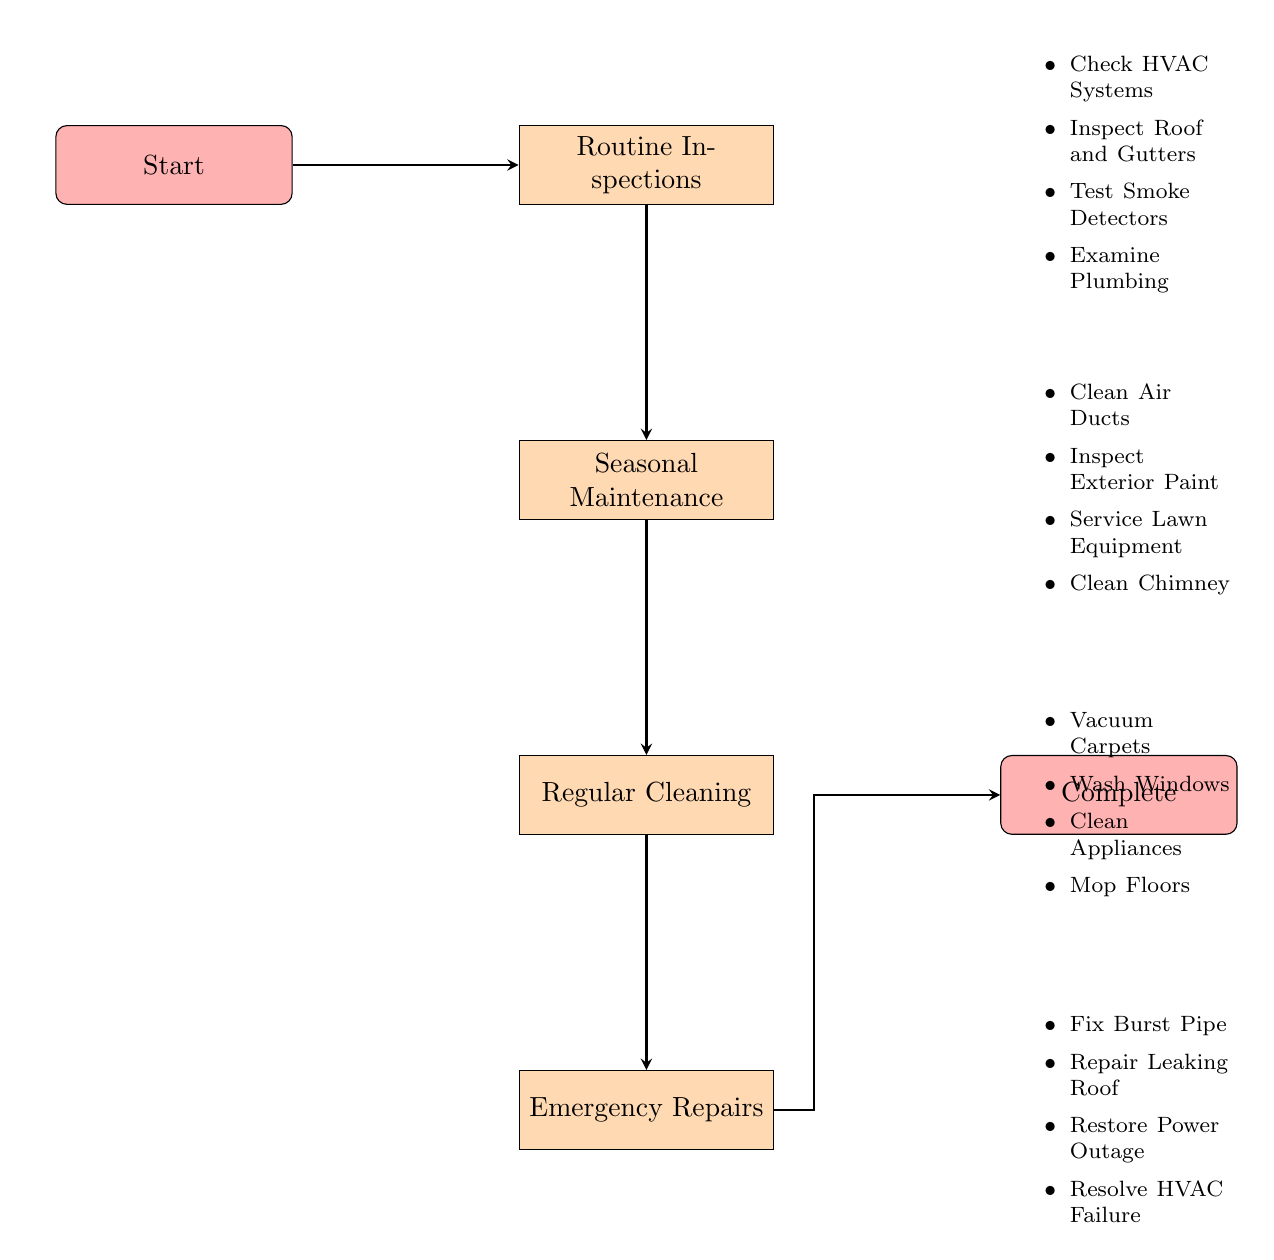What is the first node in the diagram? The first node in the diagram is labeled "Routine Inspections", which is directly after the "Start" node.
Answer: Routine Inspections How many actions are listed under "Regular Cleaning"? Counting the actions listed under "Regular Cleaning", there are four specific tasks mentioned: vacuum carpets, wash windows, clean kitchen appliances, and mop floors.
Answer: 4 What action is included in the "Emergency Repairs" node? Among the actions included in "Emergency Repairs", one specific task is to "Fix Burst Pipe".
Answer: Fix Burst Pipe What type of maintenance is done before "Seasonal Maintenance"? The type of maintenance that is done before "Seasonal Maintenance" is "Routine Inspections", which is directly linked in the flow chart to precede it.
Answer: Routine Inspections Which node follows "Regular Cleaning"? The node that follows "Regular Cleaning" in the flow of the diagram is "Emergency Repairs".
Answer: Emergency Repairs What is the last node in the flow chart? The last node in the flow chart, after all actions are completed, is labeled "Complete".
Answer: Complete What is the relationship between "Routine Inspections" and "Emergency Repairs"? "Routine Inspections" is the first step that leads to "Seasonal Maintenance", "Regular Cleaning", and then finally to "Emergency Repairs", establishing a sequential relationship through the flow of the chart.
Answer: Sequential Relationship How many total nodes are present in the diagram? There are five total nodes in the diagram, which consist of "Start", "Routine Inspections", "Seasonal Maintenance", "Regular Cleaning", "Emergency Repairs", and "Complete".
Answer: 5 